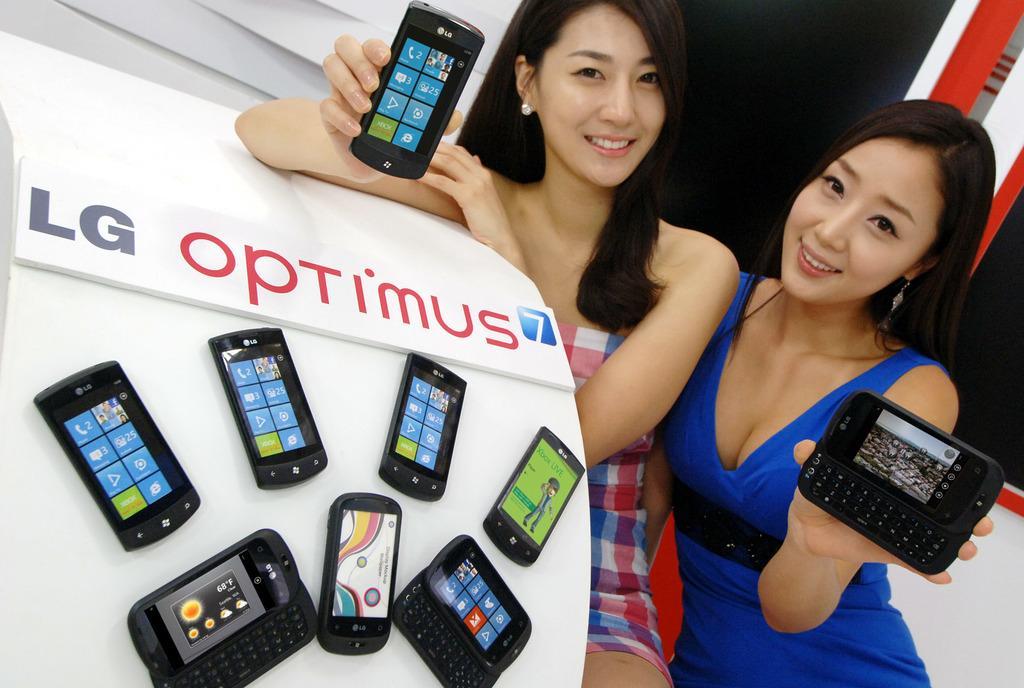Describe this image in one or two sentences. In this picture we can see two women holding mobiles with their hands and sitting and smiling and beside to them we can see mobiles on a platform. 